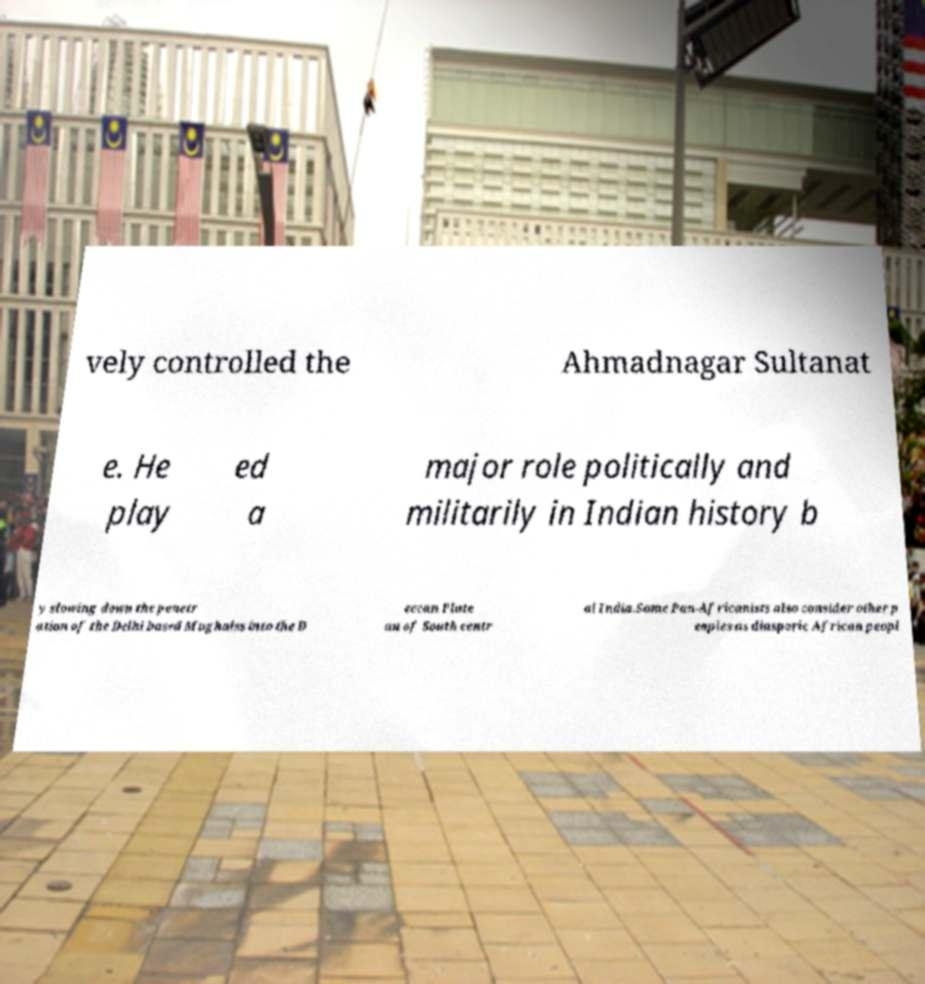Could you extract and type out the text from this image? vely controlled the Ahmadnagar Sultanat e. He play ed a major role politically and militarily in Indian history b y slowing down the penetr ation of the Delhi based Mughalss into the D eccan Plate au of South centr al India.Some Pan-Africanists also consider other p eoples as diasporic African peopl 